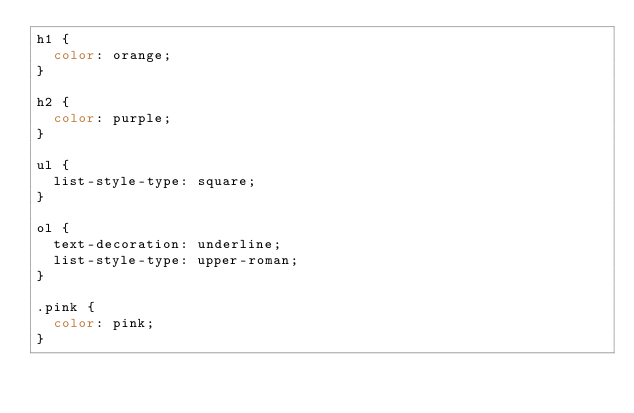<code> <loc_0><loc_0><loc_500><loc_500><_CSS_>h1 {
  color: orange;
}

h2 {
  color: purple;
}

ul {
  list-style-type: square;
}

ol {
  text-decoration: underline;
  list-style-type: upper-roman;
}

.pink {
  color: pink;
}</code> 